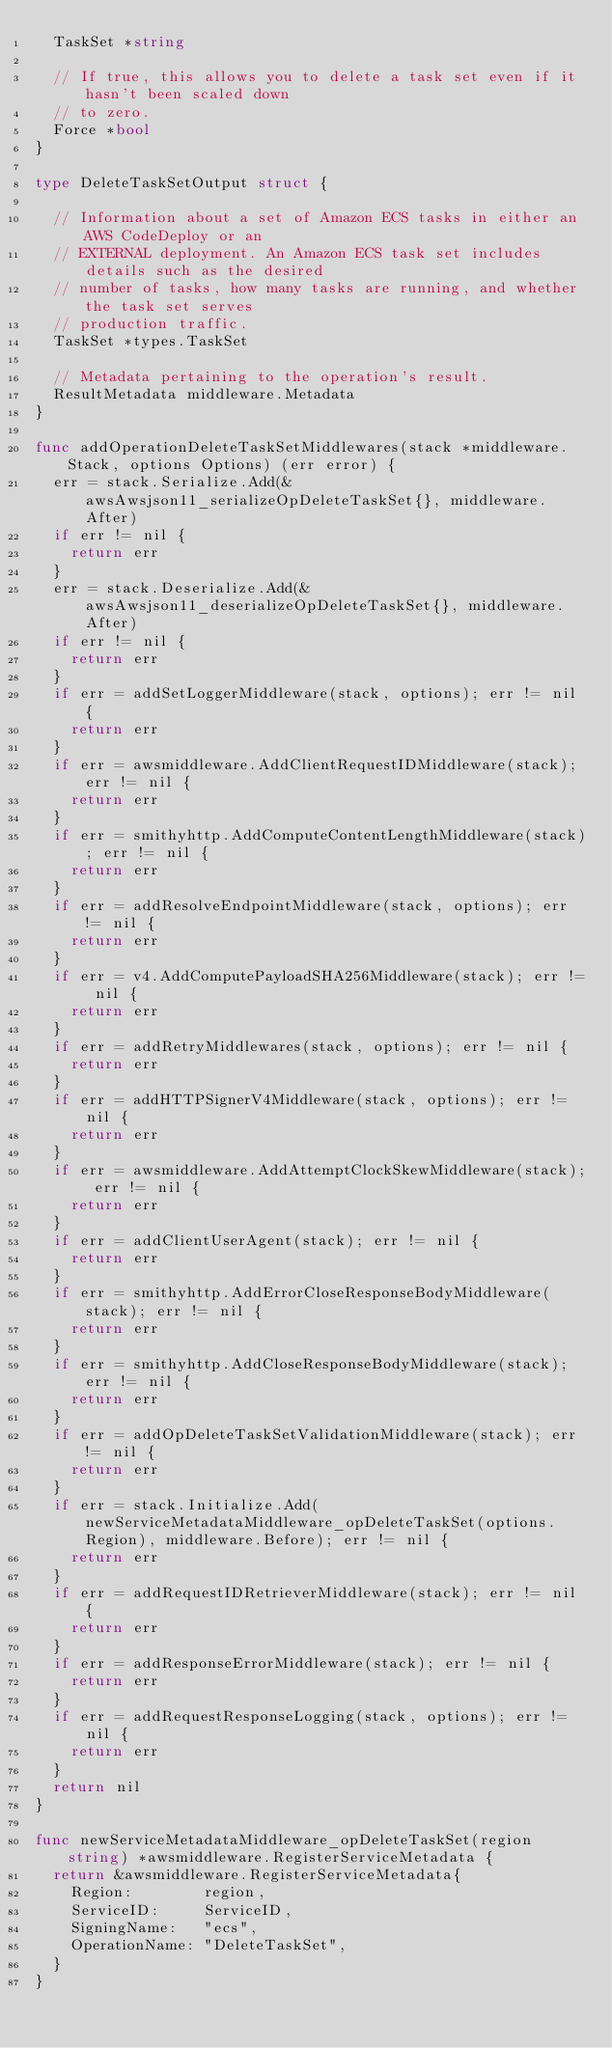<code> <loc_0><loc_0><loc_500><loc_500><_Go_>	TaskSet *string

	// If true, this allows you to delete a task set even if it hasn't been scaled down
	// to zero.
	Force *bool
}

type DeleteTaskSetOutput struct {

	// Information about a set of Amazon ECS tasks in either an AWS CodeDeploy or an
	// EXTERNAL deployment. An Amazon ECS task set includes details such as the desired
	// number of tasks, how many tasks are running, and whether the task set serves
	// production traffic.
	TaskSet *types.TaskSet

	// Metadata pertaining to the operation's result.
	ResultMetadata middleware.Metadata
}

func addOperationDeleteTaskSetMiddlewares(stack *middleware.Stack, options Options) (err error) {
	err = stack.Serialize.Add(&awsAwsjson11_serializeOpDeleteTaskSet{}, middleware.After)
	if err != nil {
		return err
	}
	err = stack.Deserialize.Add(&awsAwsjson11_deserializeOpDeleteTaskSet{}, middleware.After)
	if err != nil {
		return err
	}
	if err = addSetLoggerMiddleware(stack, options); err != nil {
		return err
	}
	if err = awsmiddleware.AddClientRequestIDMiddleware(stack); err != nil {
		return err
	}
	if err = smithyhttp.AddComputeContentLengthMiddleware(stack); err != nil {
		return err
	}
	if err = addResolveEndpointMiddleware(stack, options); err != nil {
		return err
	}
	if err = v4.AddComputePayloadSHA256Middleware(stack); err != nil {
		return err
	}
	if err = addRetryMiddlewares(stack, options); err != nil {
		return err
	}
	if err = addHTTPSignerV4Middleware(stack, options); err != nil {
		return err
	}
	if err = awsmiddleware.AddAttemptClockSkewMiddleware(stack); err != nil {
		return err
	}
	if err = addClientUserAgent(stack); err != nil {
		return err
	}
	if err = smithyhttp.AddErrorCloseResponseBodyMiddleware(stack); err != nil {
		return err
	}
	if err = smithyhttp.AddCloseResponseBodyMiddleware(stack); err != nil {
		return err
	}
	if err = addOpDeleteTaskSetValidationMiddleware(stack); err != nil {
		return err
	}
	if err = stack.Initialize.Add(newServiceMetadataMiddleware_opDeleteTaskSet(options.Region), middleware.Before); err != nil {
		return err
	}
	if err = addRequestIDRetrieverMiddleware(stack); err != nil {
		return err
	}
	if err = addResponseErrorMiddleware(stack); err != nil {
		return err
	}
	if err = addRequestResponseLogging(stack, options); err != nil {
		return err
	}
	return nil
}

func newServiceMetadataMiddleware_opDeleteTaskSet(region string) *awsmiddleware.RegisterServiceMetadata {
	return &awsmiddleware.RegisterServiceMetadata{
		Region:        region,
		ServiceID:     ServiceID,
		SigningName:   "ecs",
		OperationName: "DeleteTaskSet",
	}
}
</code> 